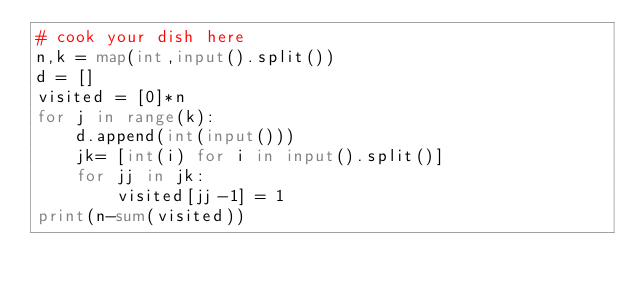Convert code to text. <code><loc_0><loc_0><loc_500><loc_500><_Python_># cook your dish here
n,k = map(int,input().split())
d = []
visited = [0]*n
for j in range(k):
    d.append(int(input()))
    jk= [int(i) for i in input().split()]
    for jj in jk:
        visited[jj-1] = 1
print(n-sum(visited))</code> 